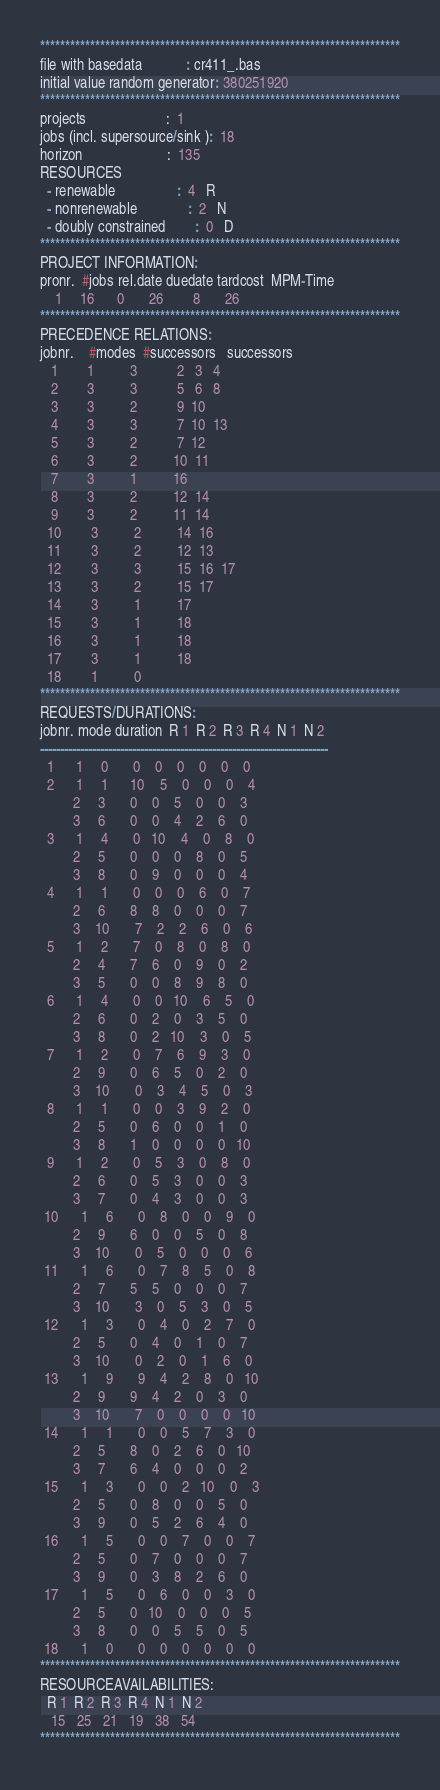Convert code to text. <code><loc_0><loc_0><loc_500><loc_500><_ObjectiveC_>************************************************************************
file with basedata            : cr411_.bas
initial value random generator: 380251920
************************************************************************
projects                      :  1
jobs (incl. supersource/sink ):  18
horizon                       :  135
RESOURCES
  - renewable                 :  4   R
  - nonrenewable              :  2   N
  - doubly constrained        :  0   D
************************************************************************
PROJECT INFORMATION:
pronr.  #jobs rel.date duedate tardcost  MPM-Time
    1     16      0       26        8       26
************************************************************************
PRECEDENCE RELATIONS:
jobnr.    #modes  #successors   successors
   1        1          3           2   3   4
   2        3          3           5   6   8
   3        3          2           9  10
   4        3          3           7  10  13
   5        3          2           7  12
   6        3          2          10  11
   7        3          1          16
   8        3          2          12  14
   9        3          2          11  14
  10        3          2          14  16
  11        3          2          12  13
  12        3          3          15  16  17
  13        3          2          15  17
  14        3          1          17
  15        3          1          18
  16        3          1          18
  17        3          1          18
  18        1          0        
************************************************************************
REQUESTS/DURATIONS:
jobnr. mode duration  R 1  R 2  R 3  R 4  N 1  N 2
------------------------------------------------------------------------
  1      1     0       0    0    0    0    0    0
  2      1     1      10    5    0    0    0    4
         2     3       0    0    5    0    0    3
         3     6       0    0    4    2    6    0
  3      1     4       0   10    4    0    8    0
         2     5       0    0    0    8    0    5
         3     8       0    9    0    0    0    4
  4      1     1       0    0    0    6    0    7
         2     6       8    8    0    0    0    7
         3    10       7    2    2    6    0    6
  5      1     2       7    0    8    0    8    0
         2     4       7    6    0    9    0    2
         3     5       0    0    8    9    8    0
  6      1     4       0    0   10    6    5    0
         2     6       0    2    0    3    5    0
         3     8       0    2   10    3    0    5
  7      1     2       0    7    6    9    3    0
         2     9       0    6    5    0    2    0
         3    10       0    3    4    5    0    3
  8      1     1       0    0    3    9    2    0
         2     5       0    6    0    0    1    0
         3     8       1    0    0    0    0   10
  9      1     2       0    5    3    0    8    0
         2     6       0    5    3    0    0    3
         3     7       0    4    3    0    0    3
 10      1     6       0    8    0    0    9    0
         2     9       6    0    0    5    0    8
         3    10       0    5    0    0    0    6
 11      1     6       0    7    8    5    0    8
         2     7       5    5    0    0    0    7
         3    10       3    0    5    3    0    5
 12      1     3       0    4    0    2    7    0
         2     5       0    4    0    1    0    7
         3    10       0    2    0    1    6    0
 13      1     9       9    4    2    8    0   10
         2     9       9    4    2    0    3    0
         3    10       7    0    0    0    0   10
 14      1     1       0    0    5    7    3    0
         2     5       8    0    2    6    0   10
         3     7       6    4    0    0    0    2
 15      1     3       0    0    2   10    0    3
         2     5       0    8    0    0    5    0
         3     9       0    5    2    6    4    0
 16      1     5       0    0    7    0    0    7
         2     5       0    7    0    0    0    7
         3     9       0    3    8    2    6    0
 17      1     5       0    6    0    0    3    0
         2     5       0   10    0    0    0    5
         3     8       0    0    5    5    0    5
 18      1     0       0    0    0    0    0    0
************************************************************************
RESOURCEAVAILABILITIES:
  R 1  R 2  R 3  R 4  N 1  N 2
   15   25   21   19   38   54
************************************************************************
</code> 